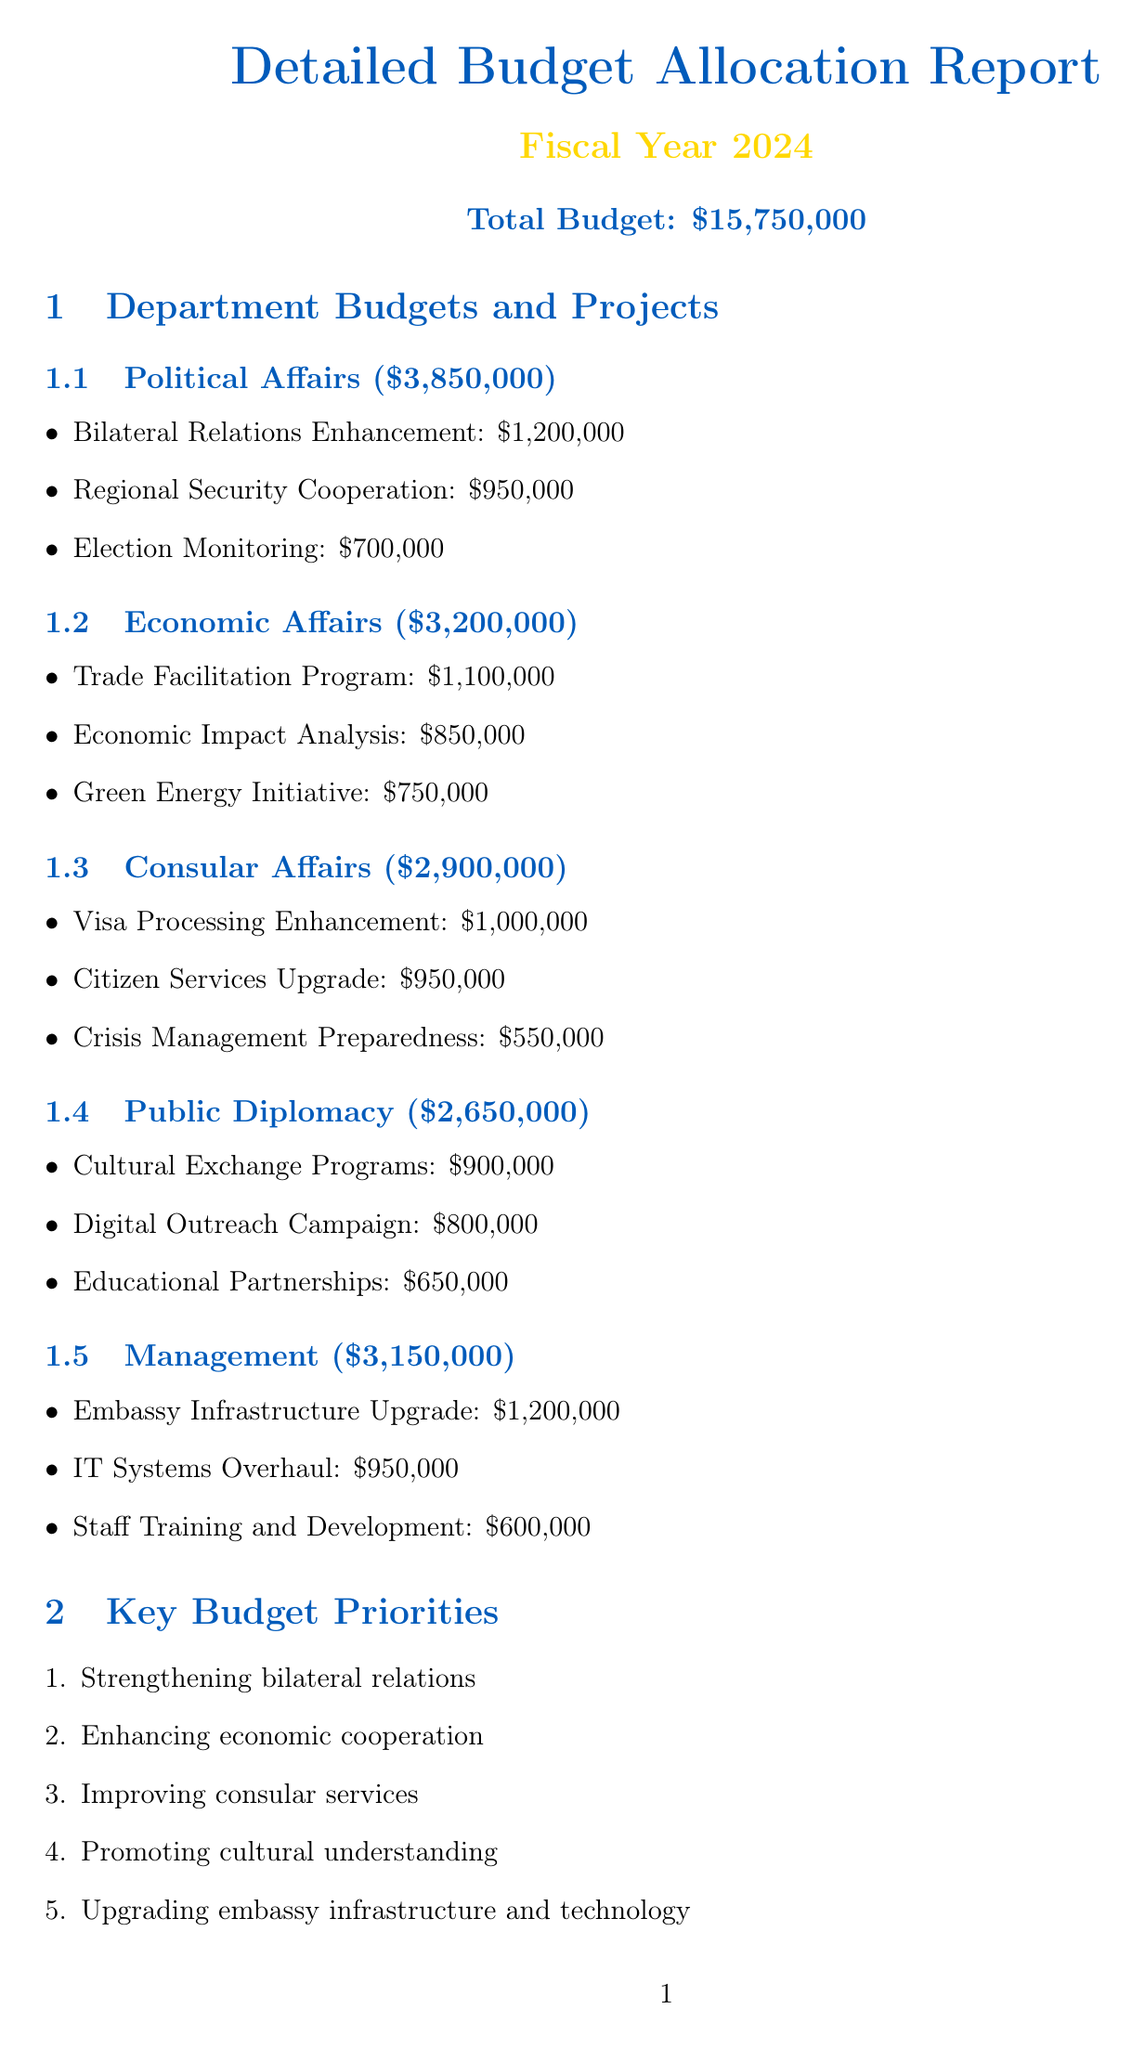What is the total budget for the fiscal year 2024? The total budget for the fiscal year 2024 is explicitly stated in the document.
Answer: $15,750,000 How much budget is allocated to Political Affairs? The budget for Political Affairs is clearly listed in the document under the corresponding section.
Answer: $3,850,000 What is the allocation for the Crisis Management Preparedness project? The document provides specific allocations for each project under their respective departments.
Answer: $550,000 Which department has a budget for the Trade Facilitation Program? The document details the projects under each department, indicating which department corresponds to the program.
Answer: Economic Affairs What are the key budget priorities for the upcoming fiscal year? The document lists key priorities in a distinct section, summarizing major focus areas.
Answer: Strengthening bilateral relations, enhancing economic cooperation, improving consular services, promoting cultural understanding, upgrading embassy infrastructure and technology What is the frequency of the internal audit as per the financial oversight section? The document specifies various financial oversight measures, including audit frequencies.
Answer: Quarterly What is the budget allocation for the Digital Outreach Campaign? The document clearly specifies the budget allocation for each project under Public Diplomacy.
Answer: $800,000 How many projects are listed under the Consular Affairs department? The document provides a comprehensive listing of projects within each department, allowing us to count them.
Answer: 3 What is the last step in the budget approval process? The steps in the budget approval process are enumerated in a clear and structured manner in the document.
Answer: Submission to State Department for final approval 